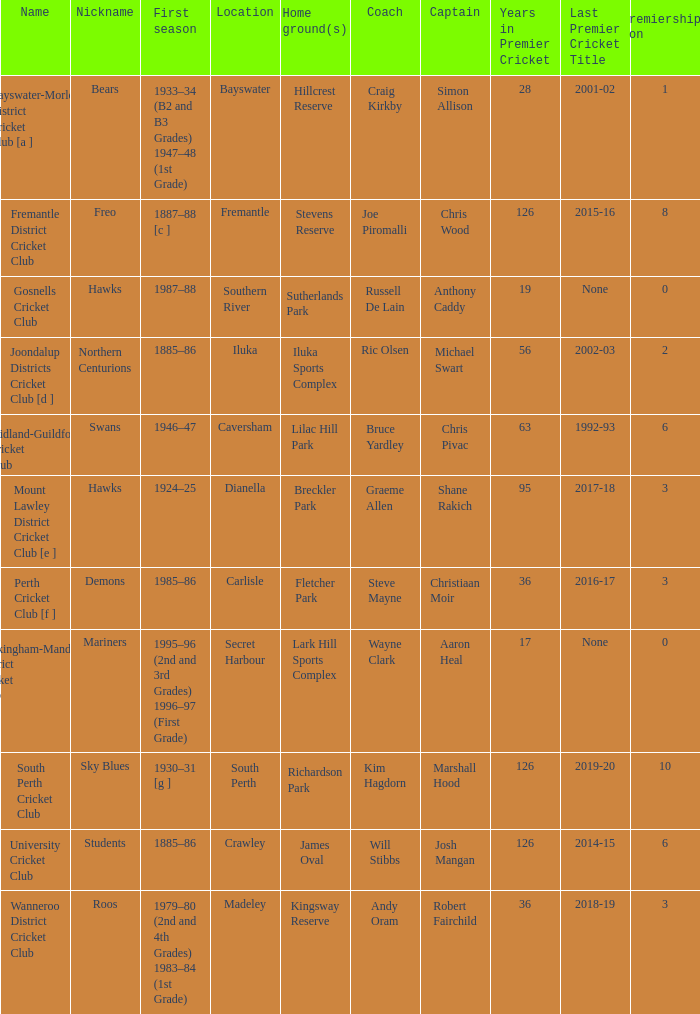With the nickname the swans, what is the home ground? Lilac Hill Park. 